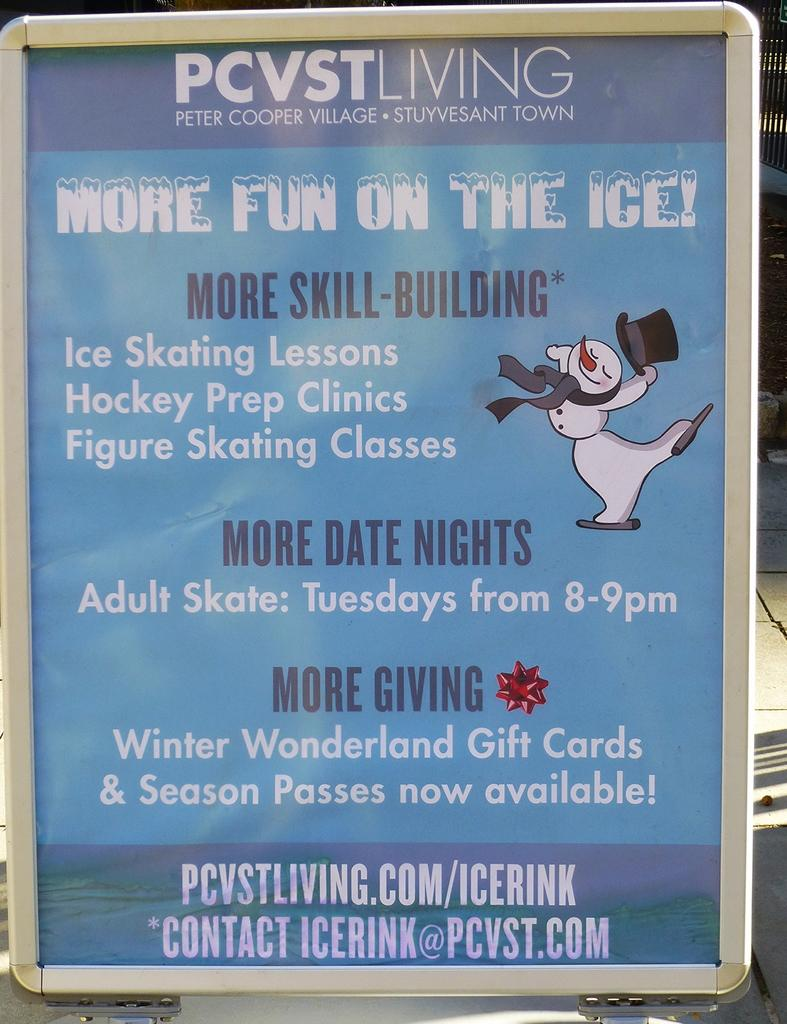<image>
Describe the image concisely. A poster stating that it is more fun on the ice 